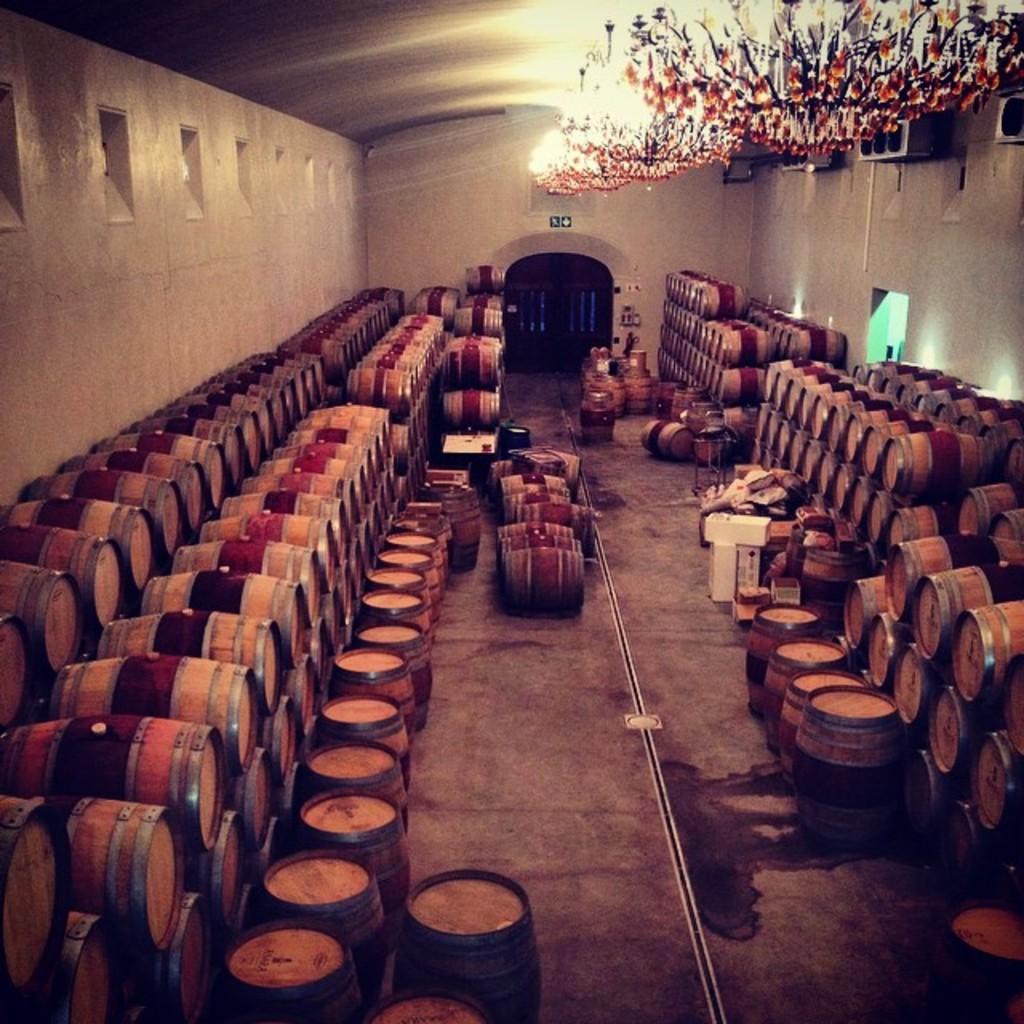In one or two sentences, can you explain what this image depicts? In this picture we can see a room with full of drums arranged in a line one after the other and in the background we can see wall, arch, chandelier, speakers, path. 